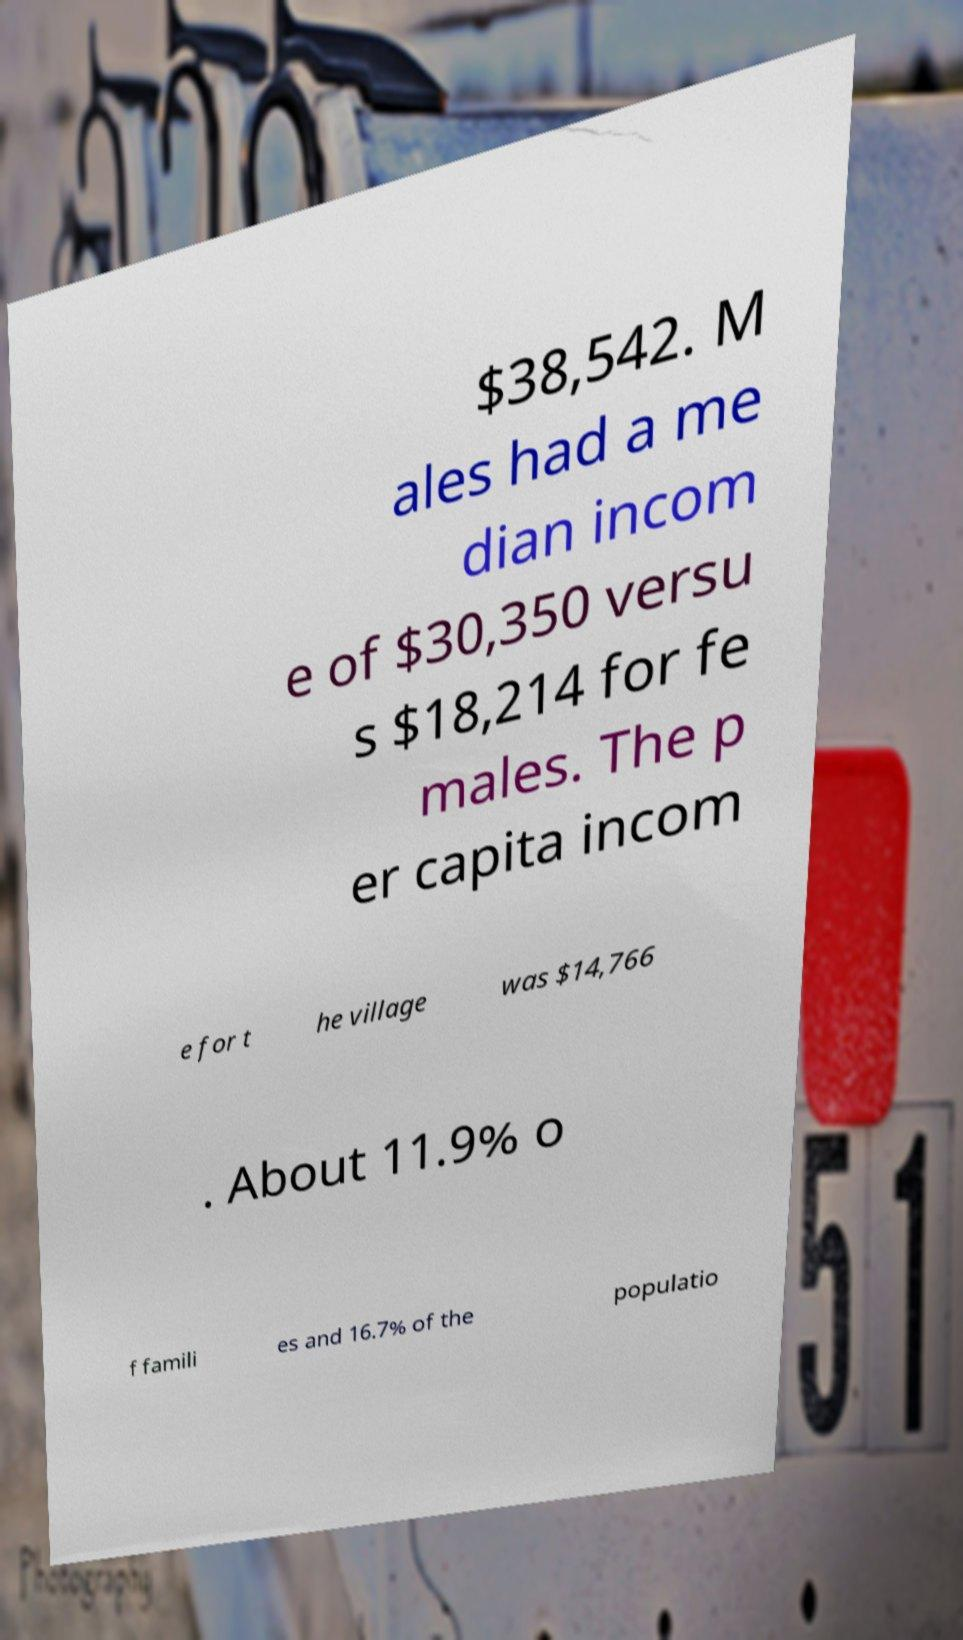Could you extract and type out the text from this image? $38,542. M ales had a me dian incom e of $30,350 versu s $18,214 for fe males. The p er capita incom e for t he village was $14,766 . About 11.9% o f famili es and 16.7% of the populatio 